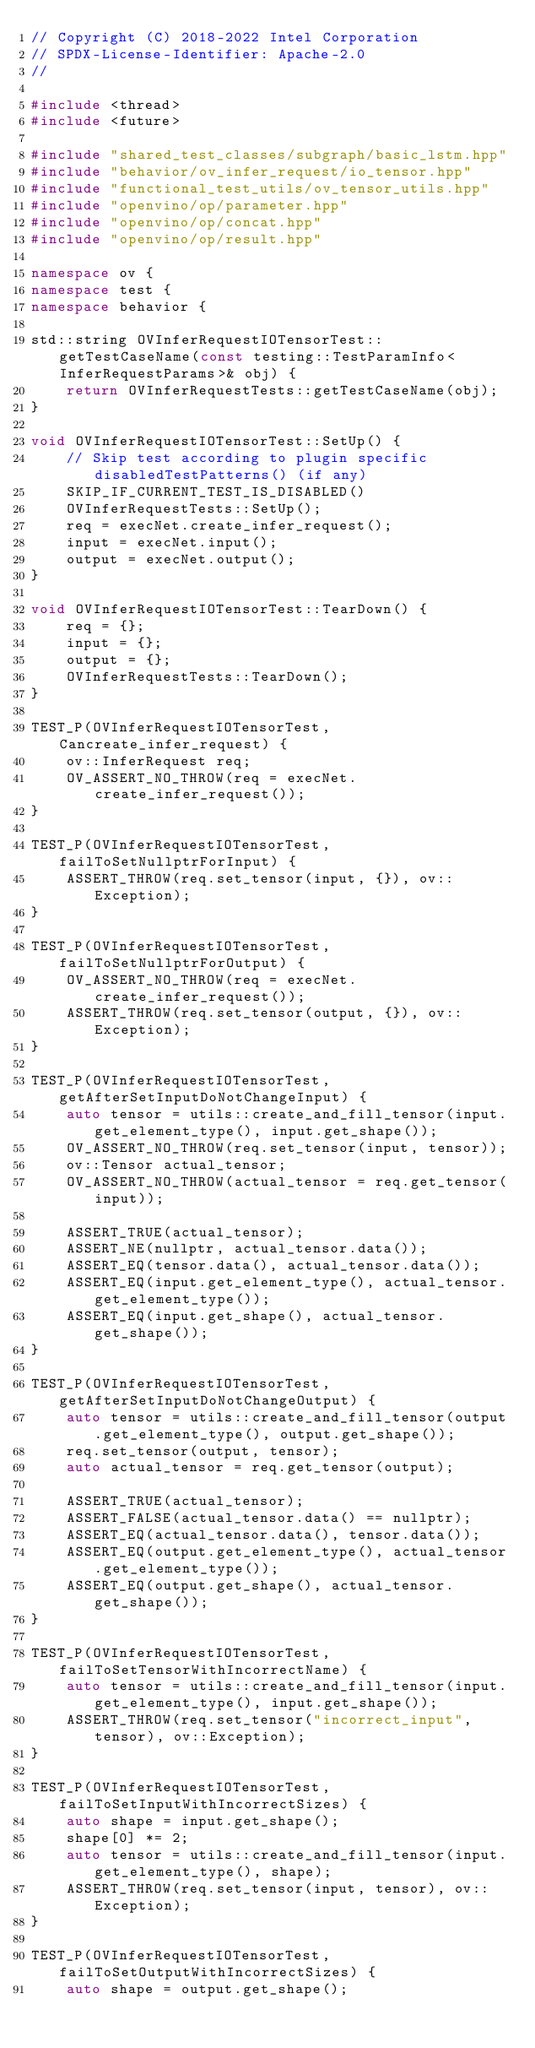Convert code to text. <code><loc_0><loc_0><loc_500><loc_500><_C++_>// Copyright (C) 2018-2022 Intel Corporation
// SPDX-License-Identifier: Apache-2.0
//

#include <thread>
#include <future>

#include "shared_test_classes/subgraph/basic_lstm.hpp"
#include "behavior/ov_infer_request/io_tensor.hpp"
#include "functional_test_utils/ov_tensor_utils.hpp"
#include "openvino/op/parameter.hpp"
#include "openvino/op/concat.hpp"
#include "openvino/op/result.hpp"

namespace ov {
namespace test {
namespace behavior {

std::string OVInferRequestIOTensorTest::getTestCaseName(const testing::TestParamInfo<InferRequestParams>& obj) {
    return OVInferRequestTests::getTestCaseName(obj);
}

void OVInferRequestIOTensorTest::SetUp() {
    // Skip test according to plugin specific disabledTestPatterns() (if any)
    SKIP_IF_CURRENT_TEST_IS_DISABLED()
    OVInferRequestTests::SetUp();
    req = execNet.create_infer_request();
    input = execNet.input();
    output = execNet.output();
}

void OVInferRequestIOTensorTest::TearDown() {
    req = {};
    input = {};
    output = {};
    OVInferRequestTests::TearDown();
}

TEST_P(OVInferRequestIOTensorTest, Cancreate_infer_request) {
    ov::InferRequest req;
    OV_ASSERT_NO_THROW(req = execNet.create_infer_request());
}

TEST_P(OVInferRequestIOTensorTest, failToSetNullptrForInput) {
    ASSERT_THROW(req.set_tensor(input, {}), ov::Exception);
}

TEST_P(OVInferRequestIOTensorTest, failToSetNullptrForOutput) {
    OV_ASSERT_NO_THROW(req = execNet.create_infer_request());
    ASSERT_THROW(req.set_tensor(output, {}), ov::Exception);
}

TEST_P(OVInferRequestIOTensorTest, getAfterSetInputDoNotChangeInput) {
    auto tensor = utils::create_and_fill_tensor(input.get_element_type(), input.get_shape());
    OV_ASSERT_NO_THROW(req.set_tensor(input, tensor));
    ov::Tensor actual_tensor;
    OV_ASSERT_NO_THROW(actual_tensor = req.get_tensor(input));

    ASSERT_TRUE(actual_tensor);
    ASSERT_NE(nullptr, actual_tensor.data());
    ASSERT_EQ(tensor.data(), actual_tensor.data());
    ASSERT_EQ(input.get_element_type(), actual_tensor.get_element_type());
    ASSERT_EQ(input.get_shape(), actual_tensor.get_shape());
}

TEST_P(OVInferRequestIOTensorTest, getAfterSetInputDoNotChangeOutput) {
    auto tensor = utils::create_and_fill_tensor(output.get_element_type(), output.get_shape());
    req.set_tensor(output, tensor);
    auto actual_tensor = req.get_tensor(output);

    ASSERT_TRUE(actual_tensor);
    ASSERT_FALSE(actual_tensor.data() == nullptr);
    ASSERT_EQ(actual_tensor.data(), tensor.data());
    ASSERT_EQ(output.get_element_type(), actual_tensor.get_element_type());
    ASSERT_EQ(output.get_shape(), actual_tensor.get_shape());
}

TEST_P(OVInferRequestIOTensorTest, failToSetTensorWithIncorrectName) {
    auto tensor = utils::create_and_fill_tensor(input.get_element_type(), input.get_shape());
    ASSERT_THROW(req.set_tensor("incorrect_input", tensor), ov::Exception);
}

TEST_P(OVInferRequestIOTensorTest, failToSetInputWithIncorrectSizes) {
    auto shape = input.get_shape();
    shape[0] *= 2;
    auto tensor = utils::create_and_fill_tensor(input.get_element_type(), shape);
    ASSERT_THROW(req.set_tensor(input, tensor), ov::Exception);
}

TEST_P(OVInferRequestIOTensorTest, failToSetOutputWithIncorrectSizes) {
    auto shape = output.get_shape();</code> 